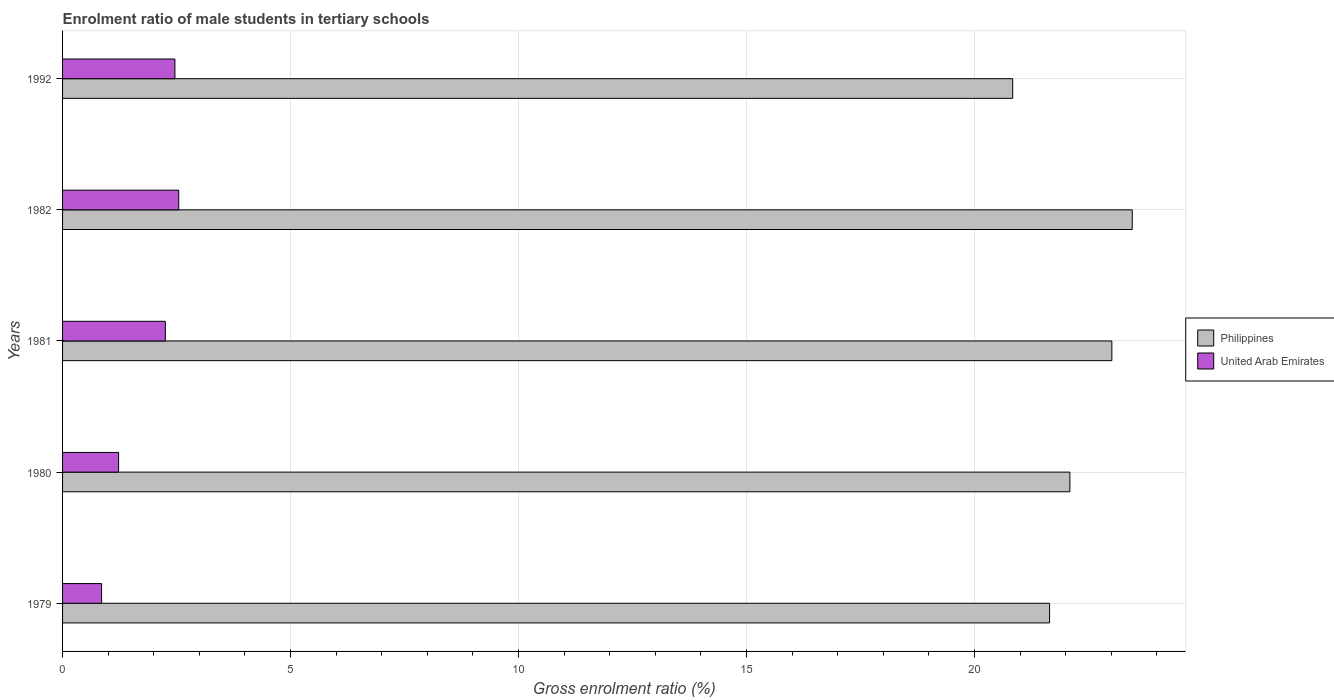Are the number of bars per tick equal to the number of legend labels?
Your answer should be compact. Yes. Are the number of bars on each tick of the Y-axis equal?
Keep it short and to the point. Yes. How many bars are there on the 3rd tick from the top?
Make the answer very short. 2. How many bars are there on the 5th tick from the bottom?
Make the answer very short. 2. What is the label of the 4th group of bars from the top?
Your answer should be compact. 1980. What is the enrolment ratio of male students in tertiary schools in Philippines in 1980?
Offer a very short reply. 22.09. Across all years, what is the maximum enrolment ratio of male students in tertiary schools in Philippines?
Provide a succinct answer. 23.46. Across all years, what is the minimum enrolment ratio of male students in tertiary schools in Philippines?
Provide a short and direct response. 20.84. In which year was the enrolment ratio of male students in tertiary schools in United Arab Emirates maximum?
Your answer should be compact. 1982. In which year was the enrolment ratio of male students in tertiary schools in United Arab Emirates minimum?
Keep it short and to the point. 1979. What is the total enrolment ratio of male students in tertiary schools in United Arab Emirates in the graph?
Give a very brief answer. 9.35. What is the difference between the enrolment ratio of male students in tertiary schools in Philippines in 1982 and that in 1992?
Keep it short and to the point. 2.62. What is the difference between the enrolment ratio of male students in tertiary schools in United Arab Emirates in 1980 and the enrolment ratio of male students in tertiary schools in Philippines in 1992?
Ensure brevity in your answer.  -19.61. What is the average enrolment ratio of male students in tertiary schools in Philippines per year?
Make the answer very short. 22.21. In the year 1980, what is the difference between the enrolment ratio of male students in tertiary schools in Philippines and enrolment ratio of male students in tertiary schools in United Arab Emirates?
Offer a terse response. 20.86. What is the ratio of the enrolment ratio of male students in tertiary schools in United Arab Emirates in 1979 to that in 1981?
Your response must be concise. 0.38. Is the enrolment ratio of male students in tertiary schools in United Arab Emirates in 1980 less than that in 1992?
Give a very brief answer. Yes. Is the difference between the enrolment ratio of male students in tertiary schools in Philippines in 1979 and 1982 greater than the difference between the enrolment ratio of male students in tertiary schools in United Arab Emirates in 1979 and 1982?
Offer a terse response. No. What is the difference between the highest and the second highest enrolment ratio of male students in tertiary schools in United Arab Emirates?
Your answer should be compact. 0.08. What is the difference between the highest and the lowest enrolment ratio of male students in tertiary schools in United Arab Emirates?
Give a very brief answer. 1.69. Is the sum of the enrolment ratio of male students in tertiary schools in Philippines in 1980 and 1992 greater than the maximum enrolment ratio of male students in tertiary schools in United Arab Emirates across all years?
Make the answer very short. Yes. What does the 1st bar from the top in 1980 represents?
Provide a short and direct response. United Arab Emirates. Are all the bars in the graph horizontal?
Offer a terse response. Yes. How many years are there in the graph?
Give a very brief answer. 5. What is the difference between two consecutive major ticks on the X-axis?
Provide a succinct answer. 5. Are the values on the major ticks of X-axis written in scientific E-notation?
Make the answer very short. No. Does the graph contain grids?
Offer a very short reply. Yes. What is the title of the graph?
Keep it short and to the point. Enrolment ratio of male students in tertiary schools. Does "Czech Republic" appear as one of the legend labels in the graph?
Your answer should be compact. No. What is the label or title of the X-axis?
Make the answer very short. Gross enrolment ratio (%). What is the label or title of the Y-axis?
Your answer should be very brief. Years. What is the Gross enrolment ratio (%) in Philippines in 1979?
Make the answer very short. 21.65. What is the Gross enrolment ratio (%) in United Arab Emirates in 1979?
Your answer should be compact. 0.86. What is the Gross enrolment ratio (%) of Philippines in 1980?
Provide a short and direct response. 22.09. What is the Gross enrolment ratio (%) of United Arab Emirates in 1980?
Your answer should be compact. 1.23. What is the Gross enrolment ratio (%) in Philippines in 1981?
Keep it short and to the point. 23.01. What is the Gross enrolment ratio (%) in United Arab Emirates in 1981?
Your answer should be very brief. 2.25. What is the Gross enrolment ratio (%) of Philippines in 1982?
Ensure brevity in your answer.  23.46. What is the Gross enrolment ratio (%) of United Arab Emirates in 1982?
Provide a succinct answer. 2.55. What is the Gross enrolment ratio (%) of Philippines in 1992?
Give a very brief answer. 20.84. What is the Gross enrolment ratio (%) in United Arab Emirates in 1992?
Your response must be concise. 2.46. Across all years, what is the maximum Gross enrolment ratio (%) of Philippines?
Make the answer very short. 23.46. Across all years, what is the maximum Gross enrolment ratio (%) of United Arab Emirates?
Your answer should be very brief. 2.55. Across all years, what is the minimum Gross enrolment ratio (%) in Philippines?
Make the answer very short. 20.84. Across all years, what is the minimum Gross enrolment ratio (%) in United Arab Emirates?
Your response must be concise. 0.86. What is the total Gross enrolment ratio (%) of Philippines in the graph?
Provide a short and direct response. 111.05. What is the total Gross enrolment ratio (%) of United Arab Emirates in the graph?
Your answer should be compact. 9.35. What is the difference between the Gross enrolment ratio (%) in Philippines in 1979 and that in 1980?
Provide a short and direct response. -0.45. What is the difference between the Gross enrolment ratio (%) in United Arab Emirates in 1979 and that in 1980?
Give a very brief answer. -0.37. What is the difference between the Gross enrolment ratio (%) in Philippines in 1979 and that in 1981?
Your answer should be compact. -1.37. What is the difference between the Gross enrolment ratio (%) of United Arab Emirates in 1979 and that in 1981?
Make the answer very short. -1.4. What is the difference between the Gross enrolment ratio (%) of Philippines in 1979 and that in 1982?
Give a very brief answer. -1.81. What is the difference between the Gross enrolment ratio (%) in United Arab Emirates in 1979 and that in 1982?
Offer a terse response. -1.69. What is the difference between the Gross enrolment ratio (%) in Philippines in 1979 and that in 1992?
Give a very brief answer. 0.81. What is the difference between the Gross enrolment ratio (%) of United Arab Emirates in 1979 and that in 1992?
Give a very brief answer. -1.61. What is the difference between the Gross enrolment ratio (%) in Philippines in 1980 and that in 1981?
Your answer should be very brief. -0.92. What is the difference between the Gross enrolment ratio (%) in United Arab Emirates in 1980 and that in 1981?
Your answer should be very brief. -1.03. What is the difference between the Gross enrolment ratio (%) of Philippines in 1980 and that in 1982?
Your answer should be very brief. -1.37. What is the difference between the Gross enrolment ratio (%) of United Arab Emirates in 1980 and that in 1982?
Keep it short and to the point. -1.32. What is the difference between the Gross enrolment ratio (%) of Philippines in 1980 and that in 1992?
Your answer should be very brief. 1.25. What is the difference between the Gross enrolment ratio (%) in United Arab Emirates in 1980 and that in 1992?
Provide a succinct answer. -1.24. What is the difference between the Gross enrolment ratio (%) of Philippines in 1981 and that in 1982?
Keep it short and to the point. -0.45. What is the difference between the Gross enrolment ratio (%) of United Arab Emirates in 1981 and that in 1982?
Your answer should be compact. -0.29. What is the difference between the Gross enrolment ratio (%) in Philippines in 1981 and that in 1992?
Provide a short and direct response. 2.17. What is the difference between the Gross enrolment ratio (%) of United Arab Emirates in 1981 and that in 1992?
Ensure brevity in your answer.  -0.21. What is the difference between the Gross enrolment ratio (%) in Philippines in 1982 and that in 1992?
Your answer should be very brief. 2.62. What is the difference between the Gross enrolment ratio (%) of United Arab Emirates in 1982 and that in 1992?
Offer a terse response. 0.08. What is the difference between the Gross enrolment ratio (%) in Philippines in 1979 and the Gross enrolment ratio (%) in United Arab Emirates in 1980?
Offer a very short reply. 20.42. What is the difference between the Gross enrolment ratio (%) of Philippines in 1979 and the Gross enrolment ratio (%) of United Arab Emirates in 1981?
Offer a very short reply. 19.39. What is the difference between the Gross enrolment ratio (%) of Philippines in 1979 and the Gross enrolment ratio (%) of United Arab Emirates in 1982?
Ensure brevity in your answer.  19.1. What is the difference between the Gross enrolment ratio (%) in Philippines in 1979 and the Gross enrolment ratio (%) in United Arab Emirates in 1992?
Offer a very short reply. 19.18. What is the difference between the Gross enrolment ratio (%) in Philippines in 1980 and the Gross enrolment ratio (%) in United Arab Emirates in 1981?
Offer a terse response. 19.84. What is the difference between the Gross enrolment ratio (%) of Philippines in 1980 and the Gross enrolment ratio (%) of United Arab Emirates in 1982?
Your answer should be very brief. 19.54. What is the difference between the Gross enrolment ratio (%) of Philippines in 1980 and the Gross enrolment ratio (%) of United Arab Emirates in 1992?
Your answer should be very brief. 19.63. What is the difference between the Gross enrolment ratio (%) in Philippines in 1981 and the Gross enrolment ratio (%) in United Arab Emirates in 1982?
Provide a short and direct response. 20.46. What is the difference between the Gross enrolment ratio (%) of Philippines in 1981 and the Gross enrolment ratio (%) of United Arab Emirates in 1992?
Keep it short and to the point. 20.55. What is the difference between the Gross enrolment ratio (%) of Philippines in 1982 and the Gross enrolment ratio (%) of United Arab Emirates in 1992?
Your answer should be very brief. 21. What is the average Gross enrolment ratio (%) of Philippines per year?
Give a very brief answer. 22.21. What is the average Gross enrolment ratio (%) in United Arab Emirates per year?
Make the answer very short. 1.87. In the year 1979, what is the difference between the Gross enrolment ratio (%) of Philippines and Gross enrolment ratio (%) of United Arab Emirates?
Keep it short and to the point. 20.79. In the year 1980, what is the difference between the Gross enrolment ratio (%) in Philippines and Gross enrolment ratio (%) in United Arab Emirates?
Offer a terse response. 20.86. In the year 1981, what is the difference between the Gross enrolment ratio (%) in Philippines and Gross enrolment ratio (%) in United Arab Emirates?
Give a very brief answer. 20.76. In the year 1982, what is the difference between the Gross enrolment ratio (%) in Philippines and Gross enrolment ratio (%) in United Arab Emirates?
Give a very brief answer. 20.91. In the year 1992, what is the difference between the Gross enrolment ratio (%) in Philippines and Gross enrolment ratio (%) in United Arab Emirates?
Offer a terse response. 18.37. What is the ratio of the Gross enrolment ratio (%) in Philippines in 1979 to that in 1980?
Offer a very short reply. 0.98. What is the ratio of the Gross enrolment ratio (%) of United Arab Emirates in 1979 to that in 1980?
Your response must be concise. 0.7. What is the ratio of the Gross enrolment ratio (%) in Philippines in 1979 to that in 1981?
Your answer should be compact. 0.94. What is the ratio of the Gross enrolment ratio (%) in United Arab Emirates in 1979 to that in 1981?
Your answer should be compact. 0.38. What is the ratio of the Gross enrolment ratio (%) in Philippines in 1979 to that in 1982?
Offer a terse response. 0.92. What is the ratio of the Gross enrolment ratio (%) in United Arab Emirates in 1979 to that in 1982?
Make the answer very short. 0.34. What is the ratio of the Gross enrolment ratio (%) in Philippines in 1979 to that in 1992?
Provide a succinct answer. 1.04. What is the ratio of the Gross enrolment ratio (%) of United Arab Emirates in 1979 to that in 1992?
Your answer should be compact. 0.35. What is the ratio of the Gross enrolment ratio (%) in United Arab Emirates in 1980 to that in 1981?
Offer a terse response. 0.55. What is the ratio of the Gross enrolment ratio (%) of Philippines in 1980 to that in 1982?
Offer a terse response. 0.94. What is the ratio of the Gross enrolment ratio (%) in United Arab Emirates in 1980 to that in 1982?
Your answer should be compact. 0.48. What is the ratio of the Gross enrolment ratio (%) of Philippines in 1980 to that in 1992?
Your answer should be very brief. 1.06. What is the ratio of the Gross enrolment ratio (%) of United Arab Emirates in 1980 to that in 1992?
Keep it short and to the point. 0.5. What is the ratio of the Gross enrolment ratio (%) in Philippines in 1981 to that in 1982?
Offer a terse response. 0.98. What is the ratio of the Gross enrolment ratio (%) of United Arab Emirates in 1981 to that in 1982?
Make the answer very short. 0.88. What is the ratio of the Gross enrolment ratio (%) in Philippines in 1981 to that in 1992?
Provide a short and direct response. 1.1. What is the ratio of the Gross enrolment ratio (%) in United Arab Emirates in 1981 to that in 1992?
Keep it short and to the point. 0.91. What is the ratio of the Gross enrolment ratio (%) of Philippines in 1982 to that in 1992?
Offer a very short reply. 1.13. What is the ratio of the Gross enrolment ratio (%) in United Arab Emirates in 1982 to that in 1992?
Your response must be concise. 1.03. What is the difference between the highest and the second highest Gross enrolment ratio (%) of Philippines?
Offer a very short reply. 0.45. What is the difference between the highest and the second highest Gross enrolment ratio (%) of United Arab Emirates?
Provide a succinct answer. 0.08. What is the difference between the highest and the lowest Gross enrolment ratio (%) of Philippines?
Keep it short and to the point. 2.62. What is the difference between the highest and the lowest Gross enrolment ratio (%) in United Arab Emirates?
Your response must be concise. 1.69. 